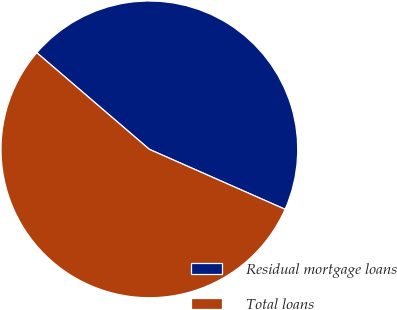Convert chart. <chart><loc_0><loc_0><loc_500><loc_500><pie_chart><fcel>Residual mortgage loans<fcel>Total loans<nl><fcel>45.33%<fcel>54.67%<nl></chart> 